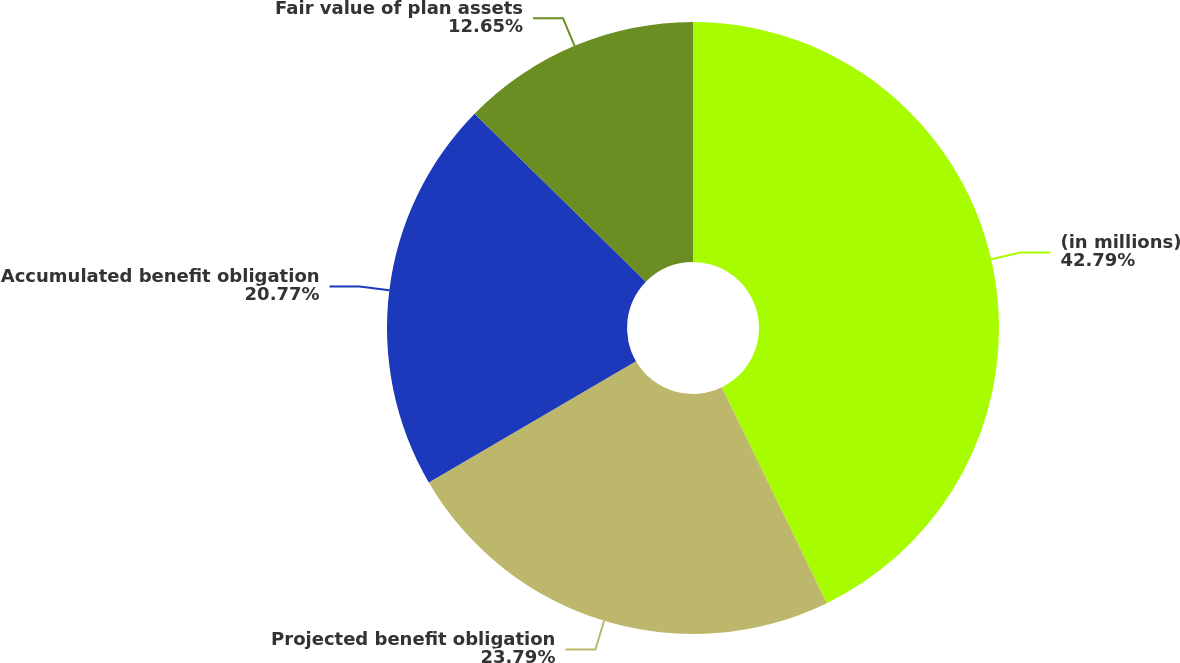<chart> <loc_0><loc_0><loc_500><loc_500><pie_chart><fcel>(in millions)<fcel>Projected benefit obligation<fcel>Accumulated benefit obligation<fcel>Fair value of plan assets<nl><fcel>42.8%<fcel>23.79%<fcel>20.77%<fcel>12.65%<nl></chart> 